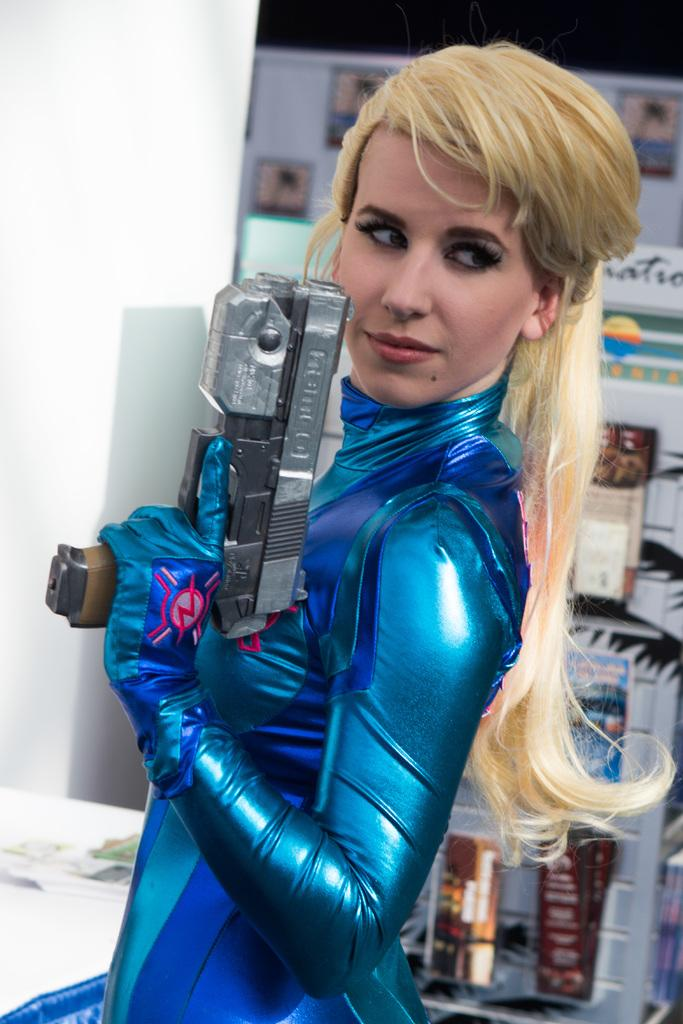Who is present in the image? There is a woman in the image. What is the woman wearing? The woman is wearing a blue dress. What is the woman holding in the image? The woman is holding a gun. What can be seen in the background of the image? There are books placed in racks in the background of the image. What type of pet is sitting next to the woman in the image? There is no pet present in the image. How many facts can be seen in the image? The term "facts" refers to pieces of information, not objects that can be seen in the image. 